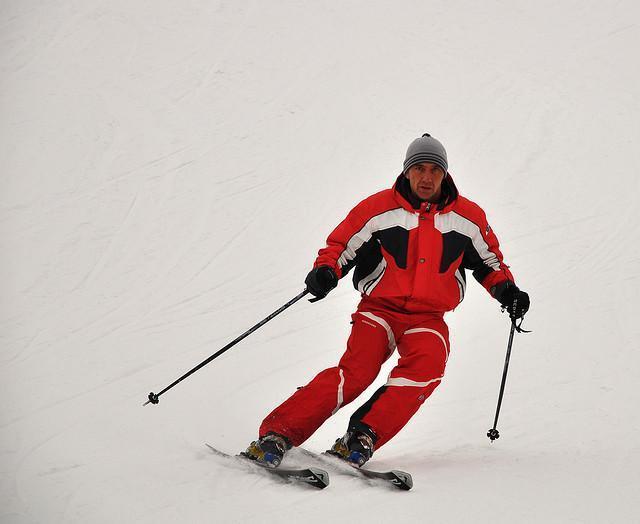How many ski can you see?
Give a very brief answer. 1. 